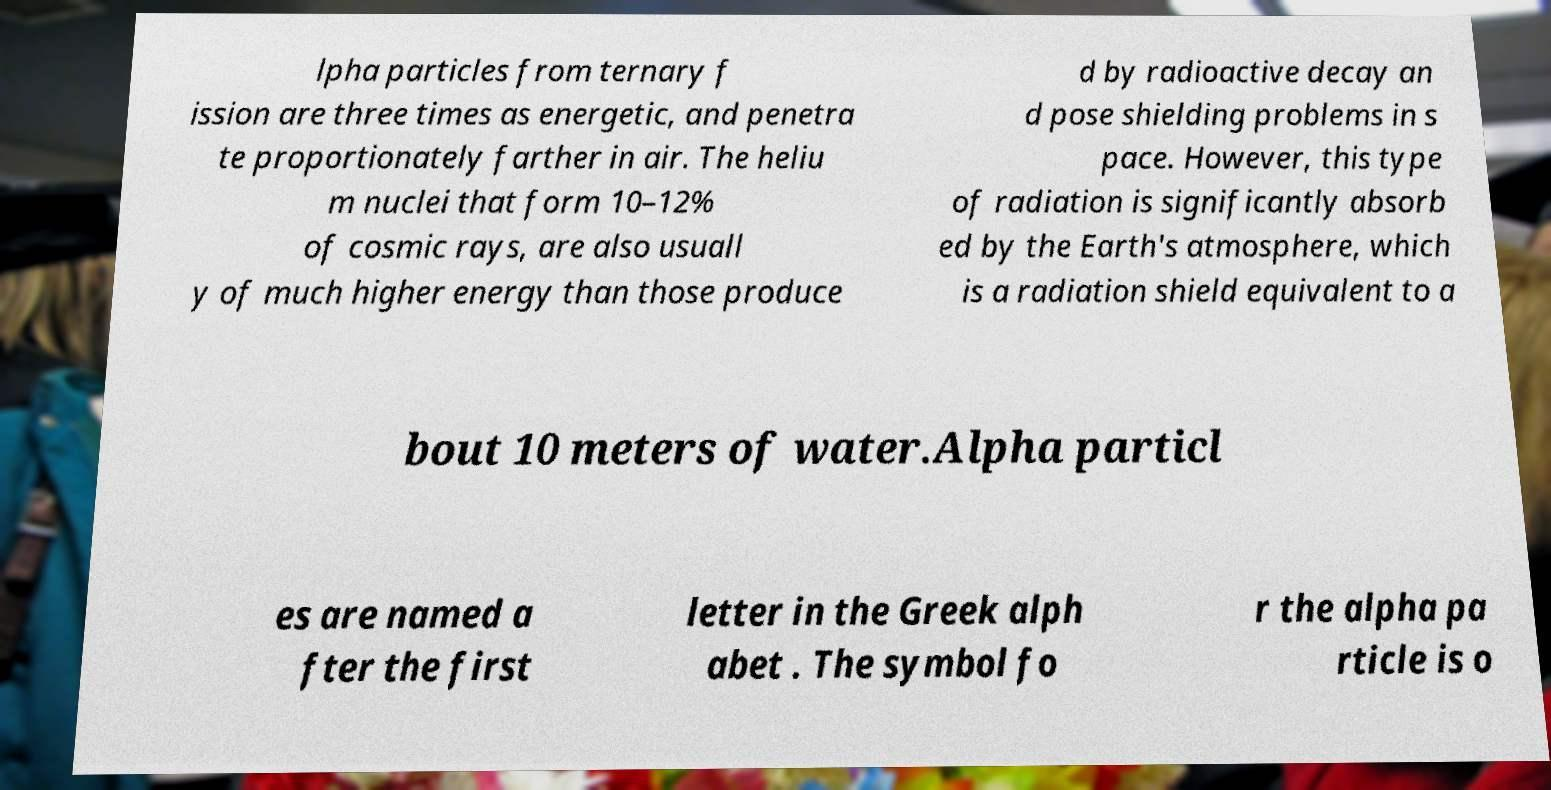There's text embedded in this image that I need extracted. Can you transcribe it verbatim? lpha particles from ternary f ission are three times as energetic, and penetra te proportionately farther in air. The heliu m nuclei that form 10–12% of cosmic rays, are also usuall y of much higher energy than those produce d by radioactive decay an d pose shielding problems in s pace. However, this type of radiation is significantly absorb ed by the Earth's atmosphere, which is a radiation shield equivalent to a bout 10 meters of water.Alpha particl es are named a fter the first letter in the Greek alph abet . The symbol fo r the alpha pa rticle is o 